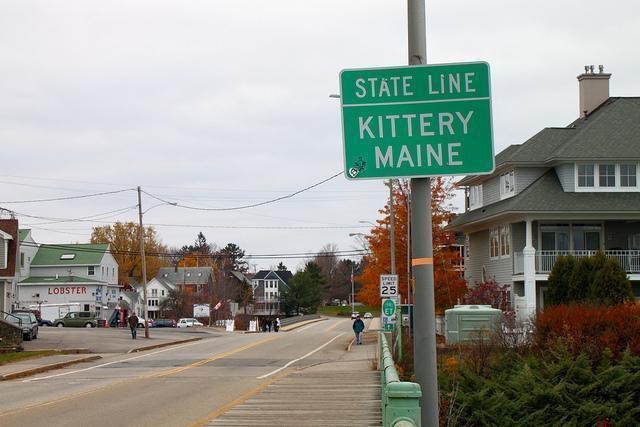What large body of water is nearest this location?
From the following four choices, select the correct answer to address the question.
Options: Arctic ocean, atlantic ocean, amazon river, mississippi river. Atlantic ocean. 